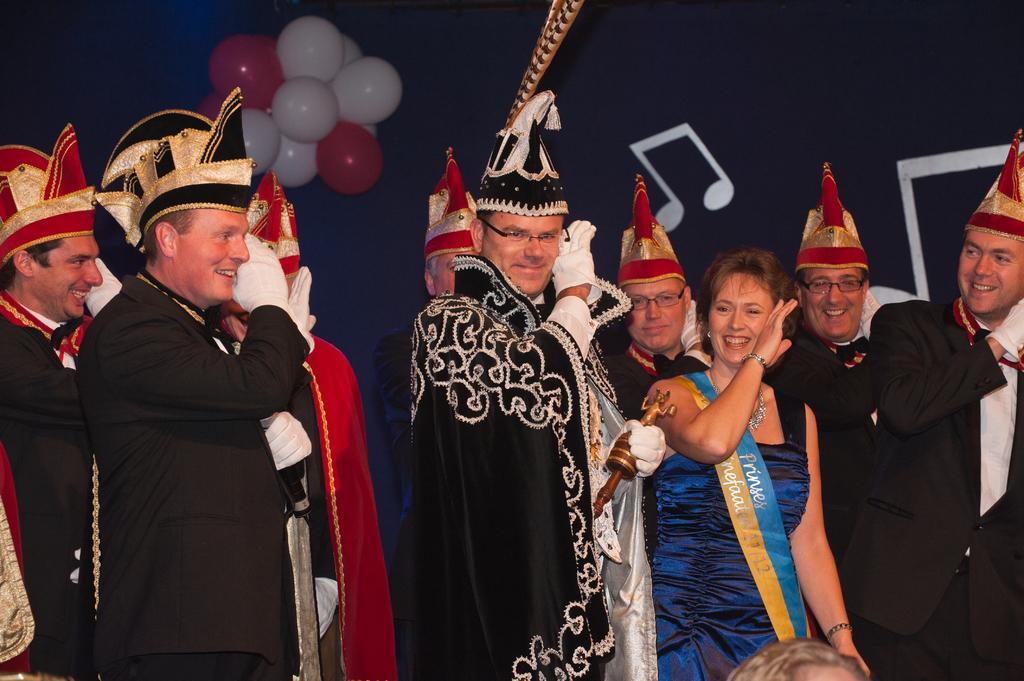Please provide a concise description of this image. Here we can see few persons and they are smiling. In the background we can see balloons. 